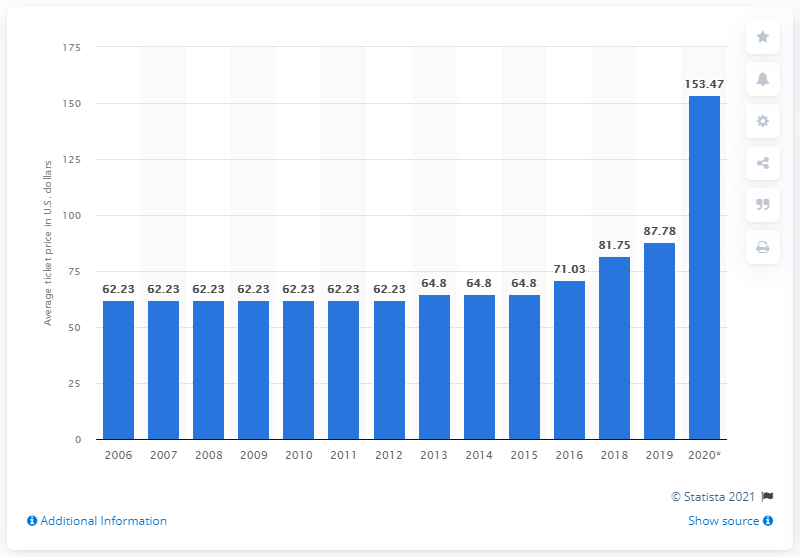Mention a couple of crucial points in this snapshot. The average ticket price for a Raiders game in 2020 was 153.47. 